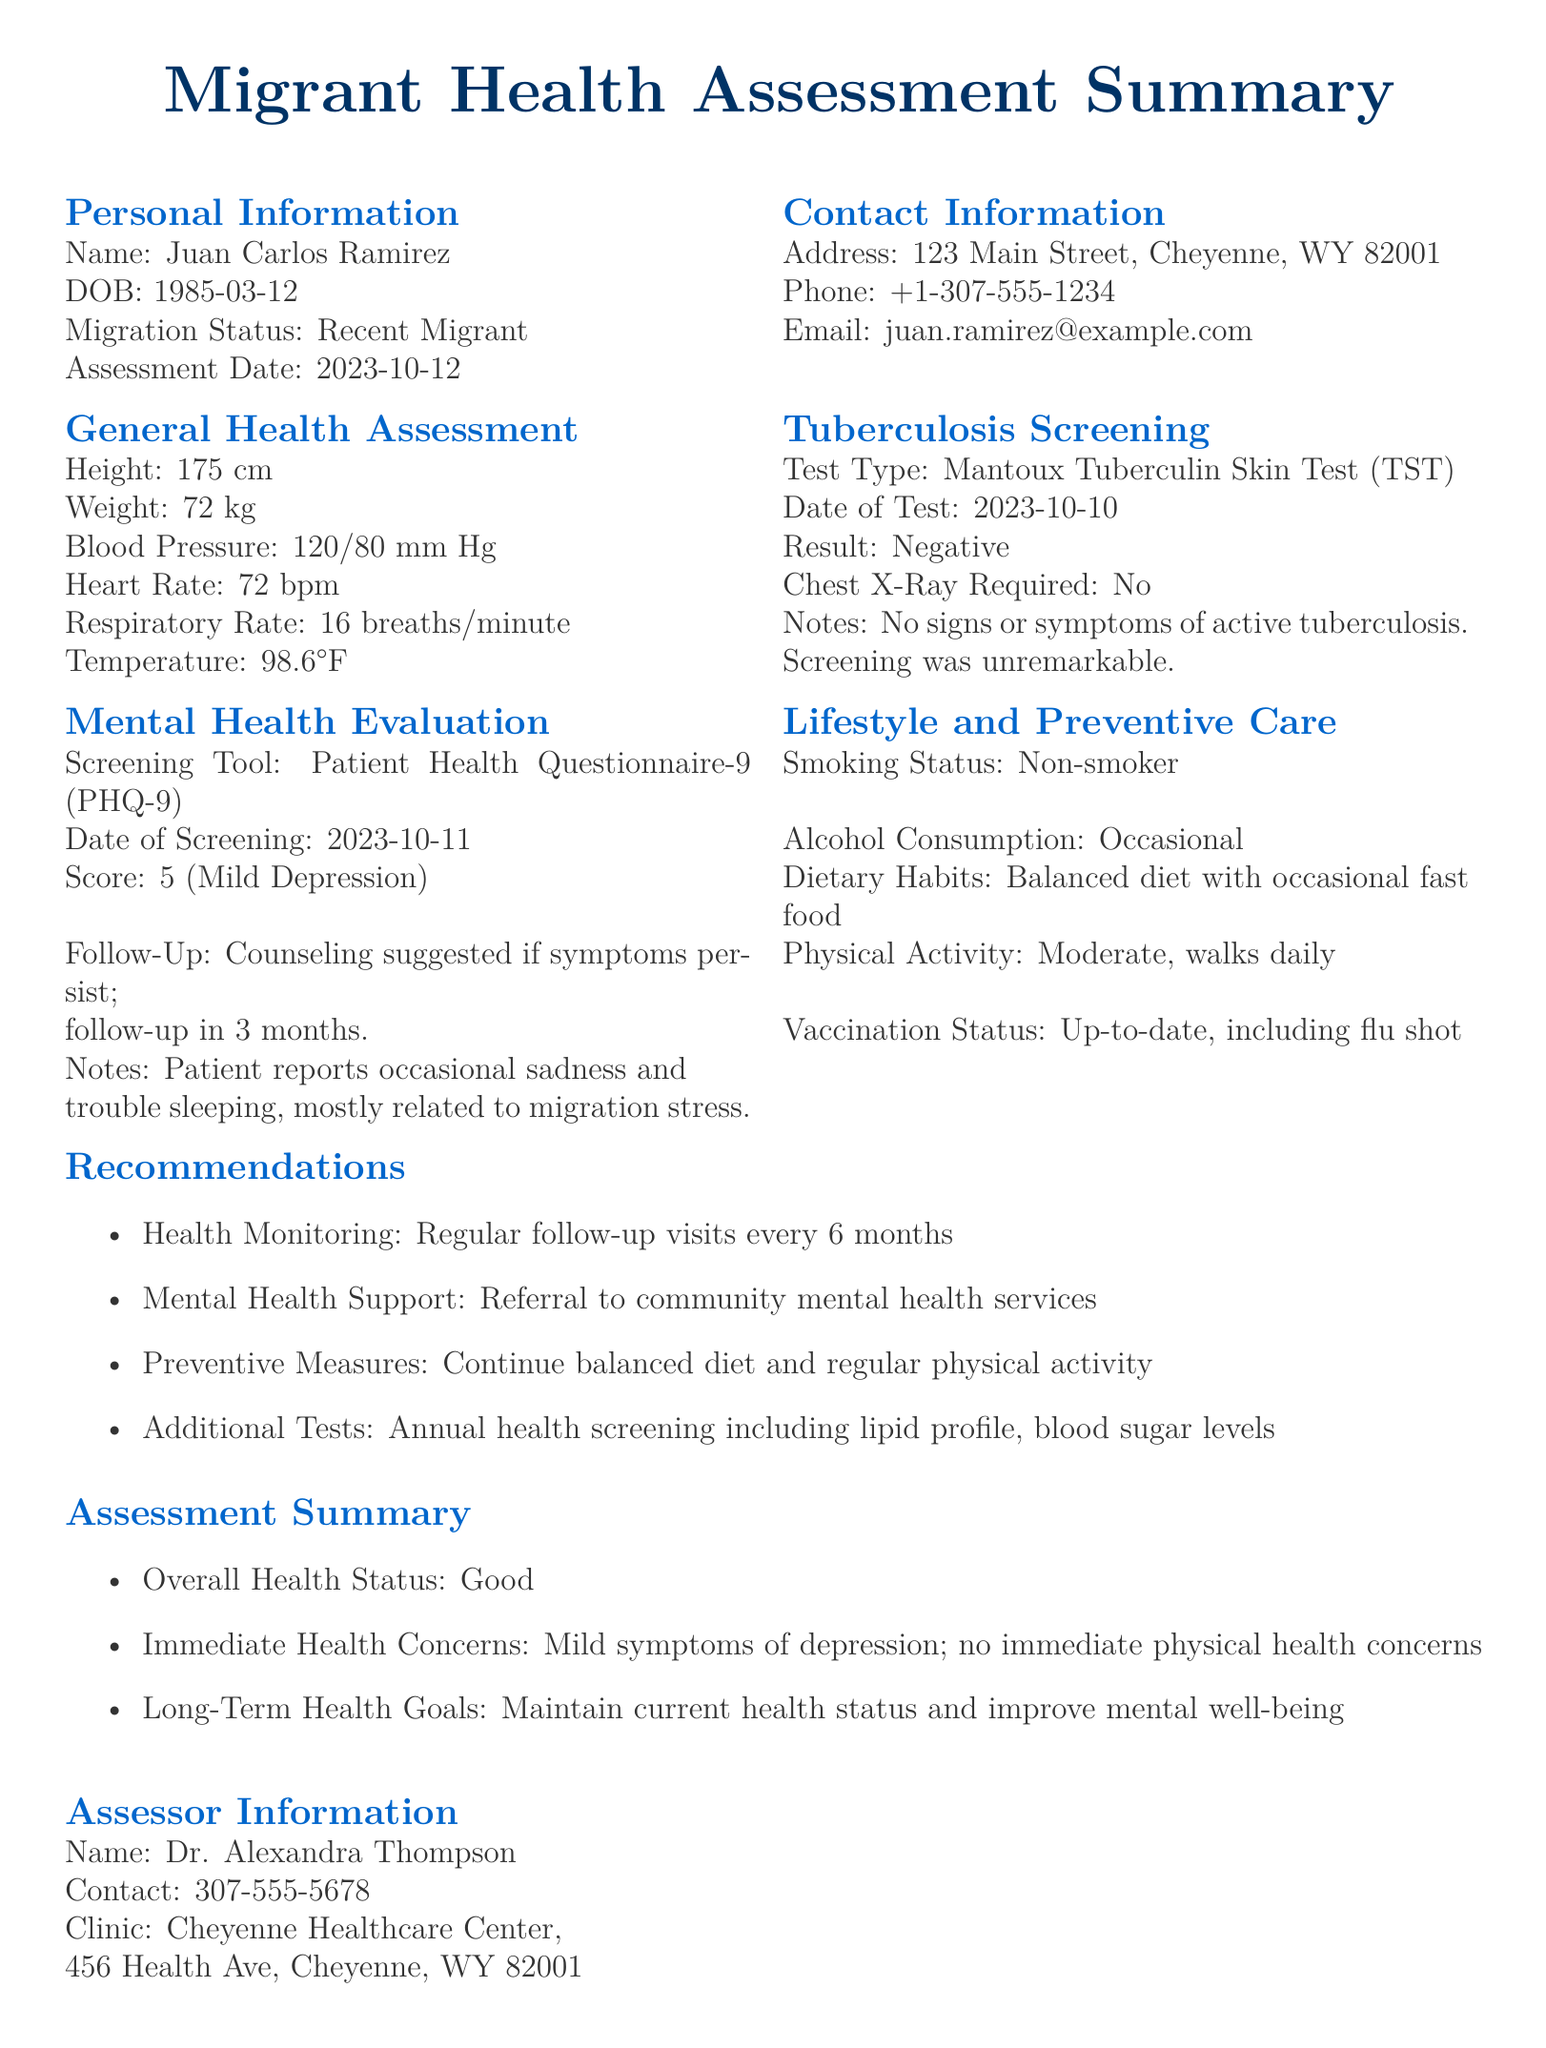What is the name of the patient? The name of the patient is listed under Personal Information section.
Answer: Juan Carlos Ramirez What is the patient's score on the PHQ-9? The score is identified in the Mental Health Evaluation section of the document.
Answer: 5 (Mild Depression) What is the date of the tuberculosis test? The date of the test can be found in the Tuberculosis Screening section.
Answer: 2023-10-10 What is the contact number for the assessor? The contact number is provided in the Assessor Information section of the document.
Answer: 307-555-5678 What follow-up is suggested for the patient? The follow-up recommendation is mentioned in the Mental Health Evaluation section.
Answer: Counseling suggested if symptoms persist What is the patient's migration status? The patient's migration status is highlighted in the Personal Information section.
Answer: Recent Migrant What is the assessment date? The assessment date is listed under Personal Information section.
Answer: 2023-10-12 What vaccination status is noted for the patient? The vaccination status can be found in the Lifestyle and Preventive Care section.
Answer: Up-to-date, including flu shot What immediate health concern does the patient have? The immediate health concern is described in the Assessment Summary section.
Answer: Mild symptoms of depression 